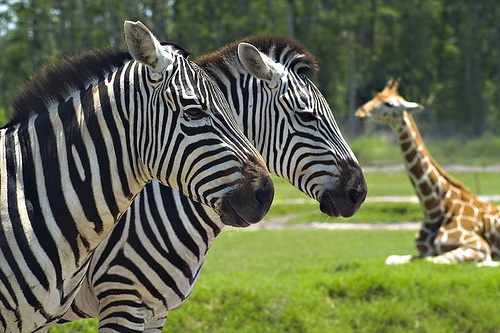Describe the objects in this image and their specific colors. I can see zebra in darkgray, black, and gray tones, zebra in darkgray, black, and gray tones, and giraffe in darkgray, gray, tan, and ivory tones in this image. 